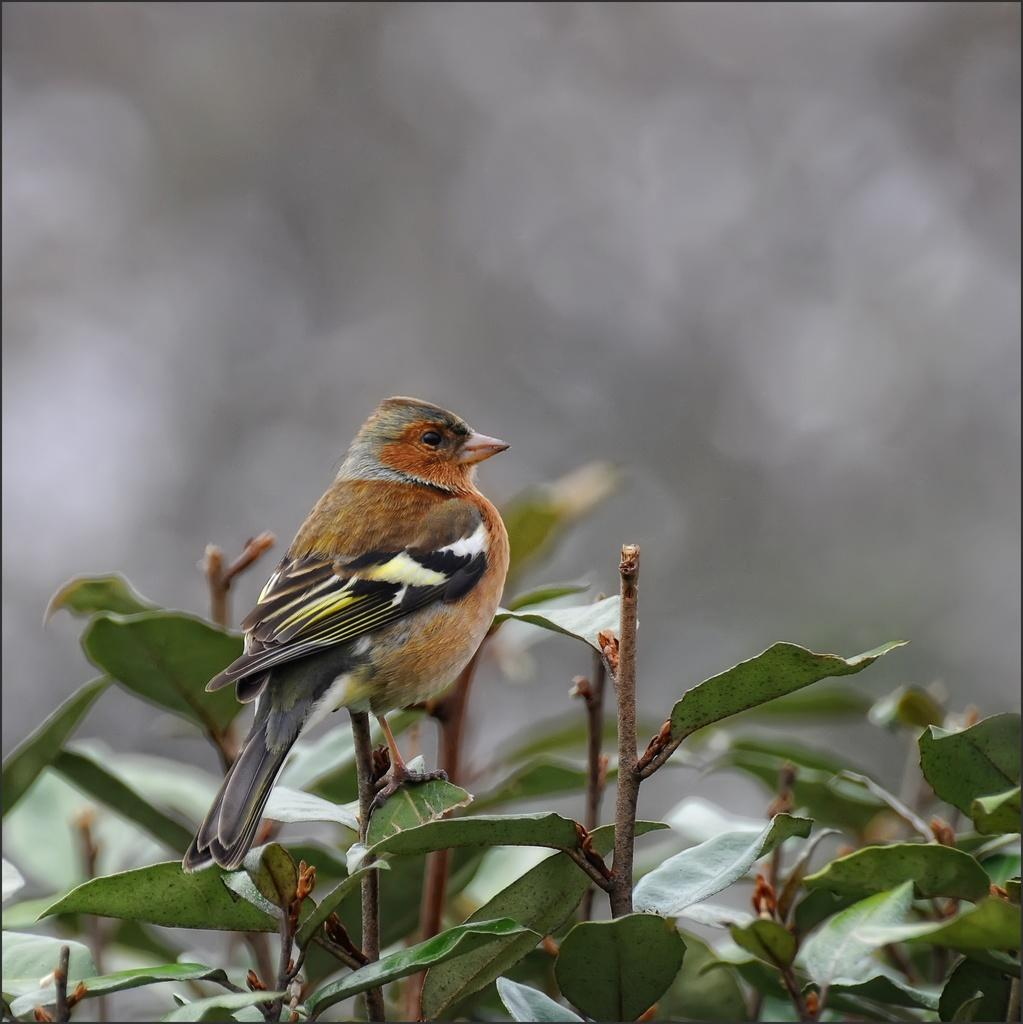What type of animal can be seen in the image? There is a bird in the image. Where is the bird located? The bird is standing on a plant. What can be observed about the plant the bird is standing on? The plant has leaves. Are there any other plants with leaves in the image? Yes, there are other plants with leaves in the image. How would you describe the background of the image? The background of the image is blurry. What type of book is the donkey reading in the image? There is no donkey or book present in the image; it features a bird standing on a plant. 